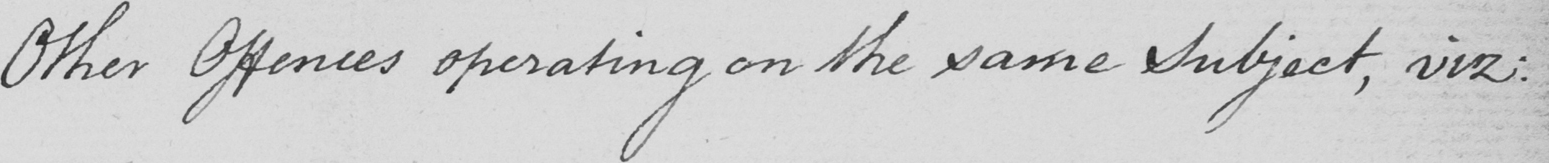Transcribe the text shown in this historical manuscript line. Other Offences operating on the same Subject , viz : 